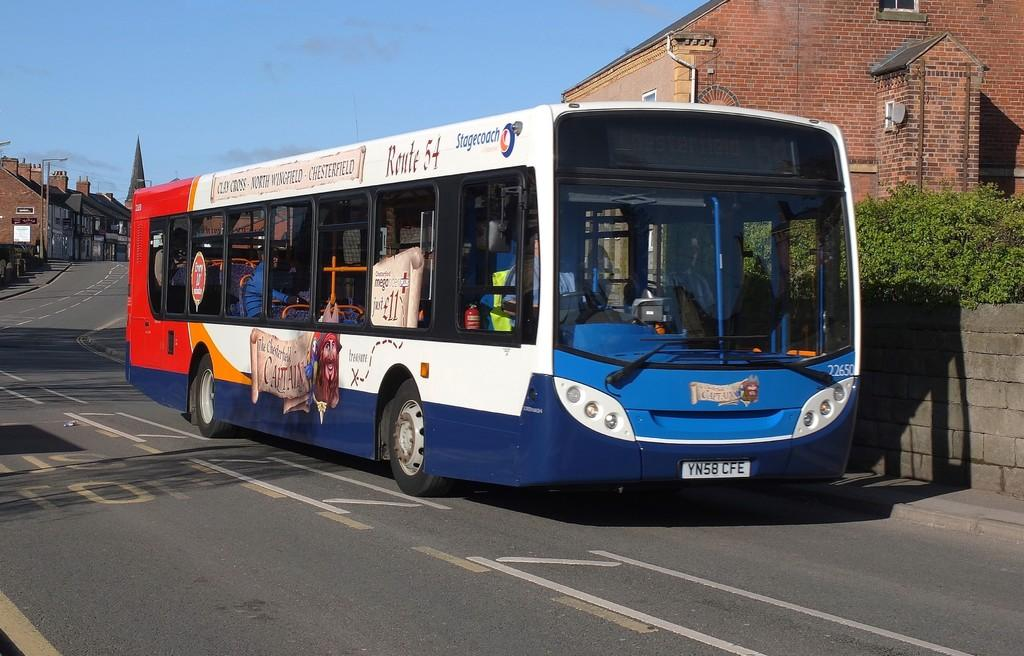<image>
Summarize the visual content of the image. a sign that has the sequence of YN58 on it 